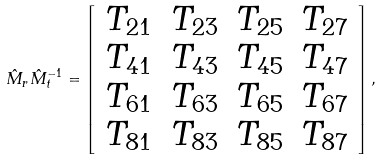<formula> <loc_0><loc_0><loc_500><loc_500>\hat { M } _ { r } \hat { M } _ { t } ^ { - 1 } = \left [ \begin{array} { c c c c } T _ { 2 1 } & T _ { 2 3 } & T _ { 2 5 } & T _ { 2 7 } \\ T _ { 4 1 } & T _ { 4 3 } & T _ { 4 5 } & T _ { 4 7 } \\ T _ { 6 1 } & T _ { 6 3 } & T _ { 6 5 } & T _ { 6 7 } \\ T _ { 8 1 } & T _ { 8 3 } & T _ { 8 5 } & T _ { 8 7 } \\ \end{array} \right ] ,</formula> 